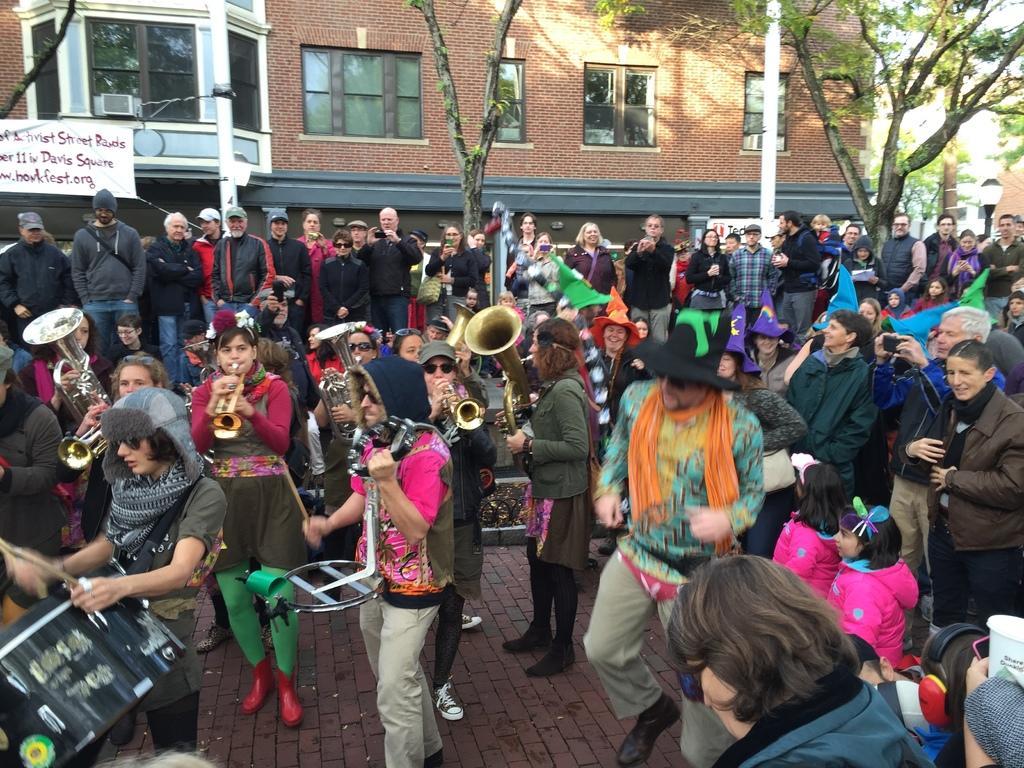Could you give a brief overview of what you see in this image? In this image we can see people standing and watching the other few people who are playing the musical instruments. In the background we can see the buildings and also trees and poles. 